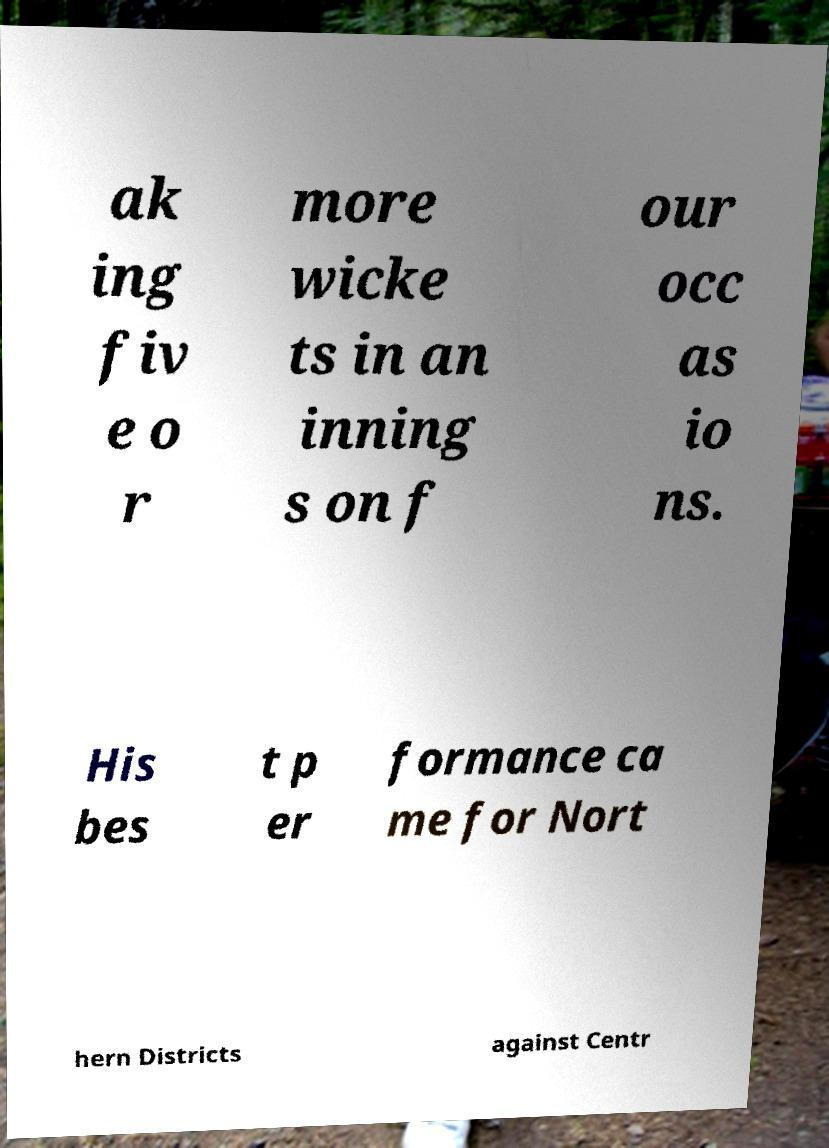What messages or text are displayed in this image? I need them in a readable, typed format. ak ing fiv e o r more wicke ts in an inning s on f our occ as io ns. His bes t p er formance ca me for Nort hern Districts against Centr 